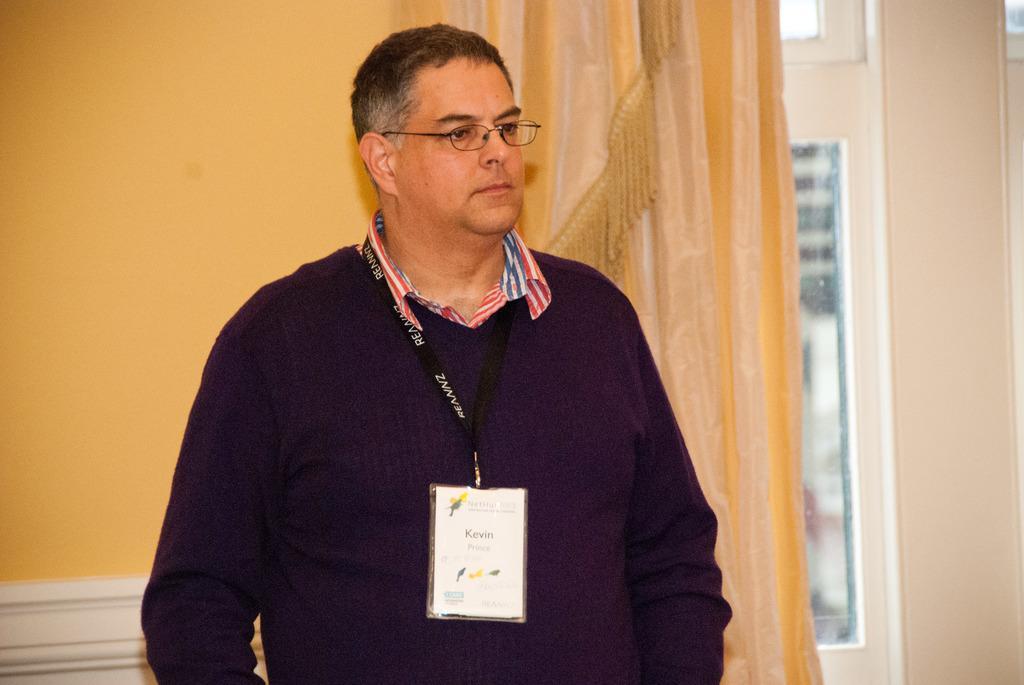How would you summarize this image in a sentence or two? In this image we can see a person wearing sweatshirt, identity card and spectacles is standing here. In the background, we can see the wall, curtains and the glass windows. 